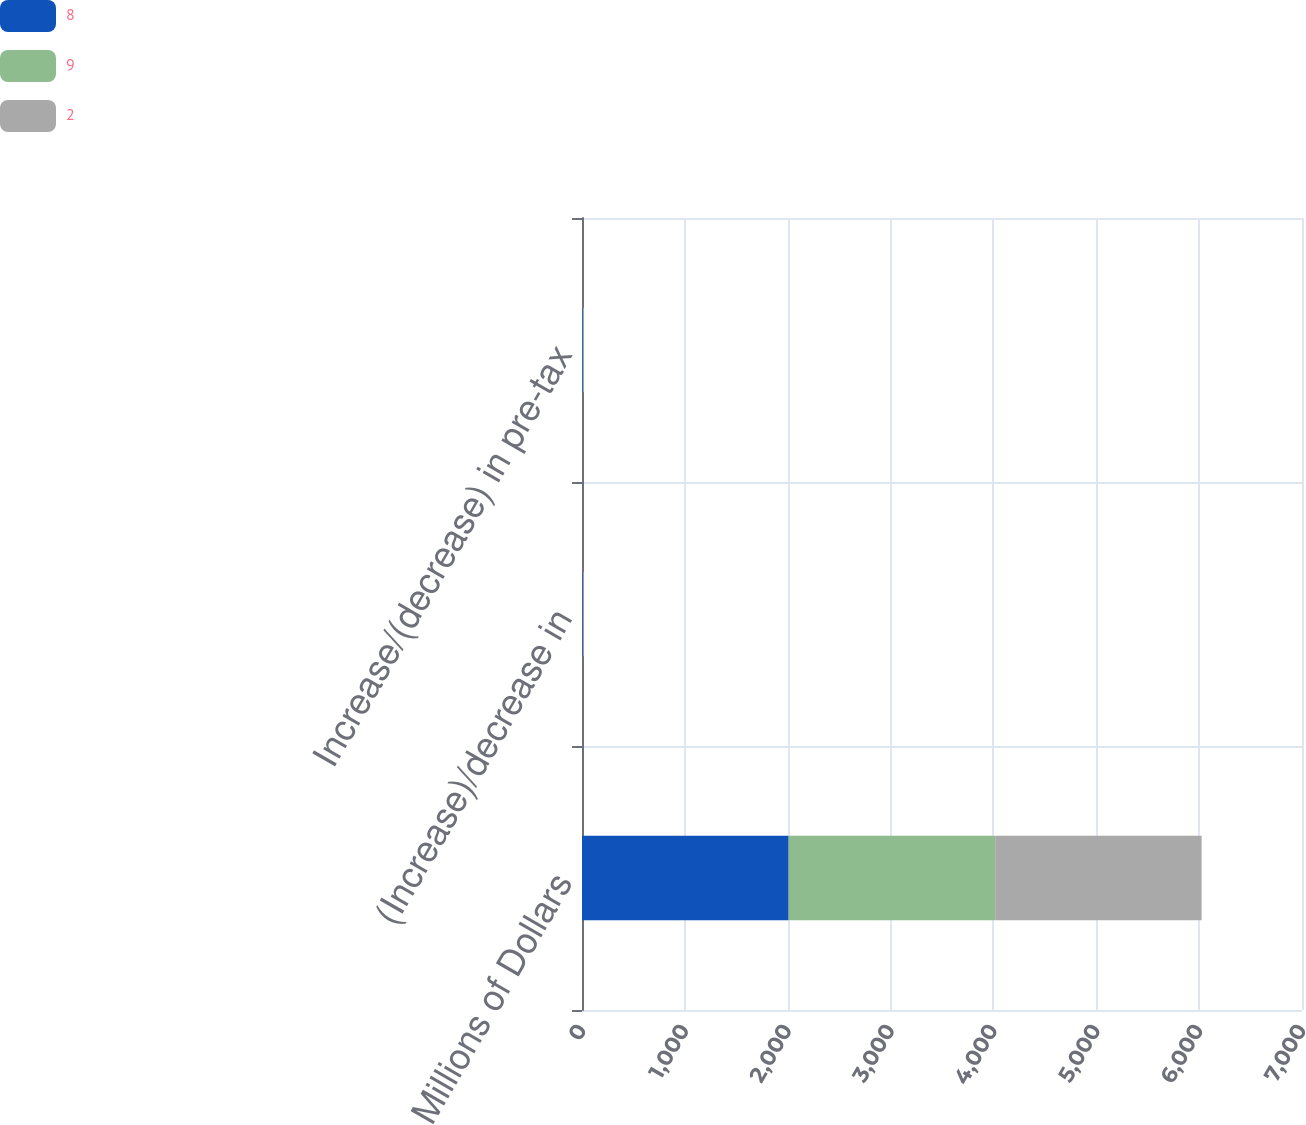Convert chart. <chart><loc_0><loc_0><loc_500><loc_500><stacked_bar_chart><ecel><fcel>Millions of Dollars<fcel>(Increase)/decrease in<fcel>Increase/(decrease) in pre-tax<nl><fcel>8<fcel>2009<fcel>8<fcel>8<nl><fcel>9<fcel>2008<fcel>1<fcel>2<nl><fcel>2<fcel>2007<fcel>8<fcel>9<nl></chart> 